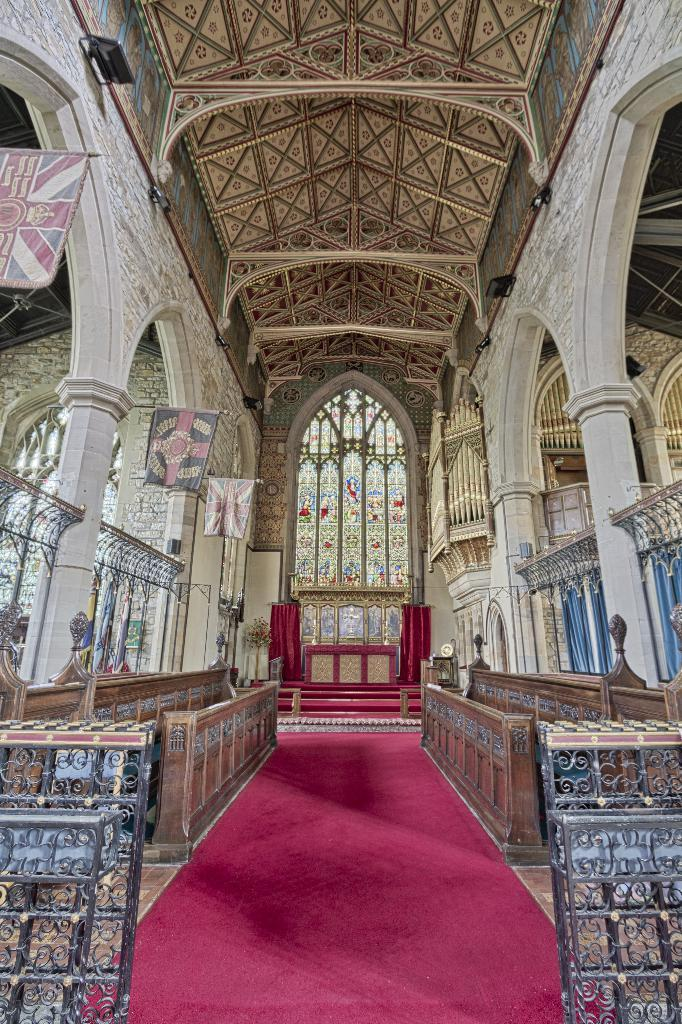What architectural features can be seen in the image? There are pillars in the image. What decorative elements are present in the image? There are banners in the image. What type of barrier can be seen in the image? There is a fence in the image. What type of flooring is visible in the image? There is a carpet in the image. What type of window treatment is present in the image? There are curtains in the image. Where is the image taken? The image is an inside view of a building. What type of trees can be seen through the windows in the image? There are no windows visible in the image, and therefore no trees can be seen through them. 